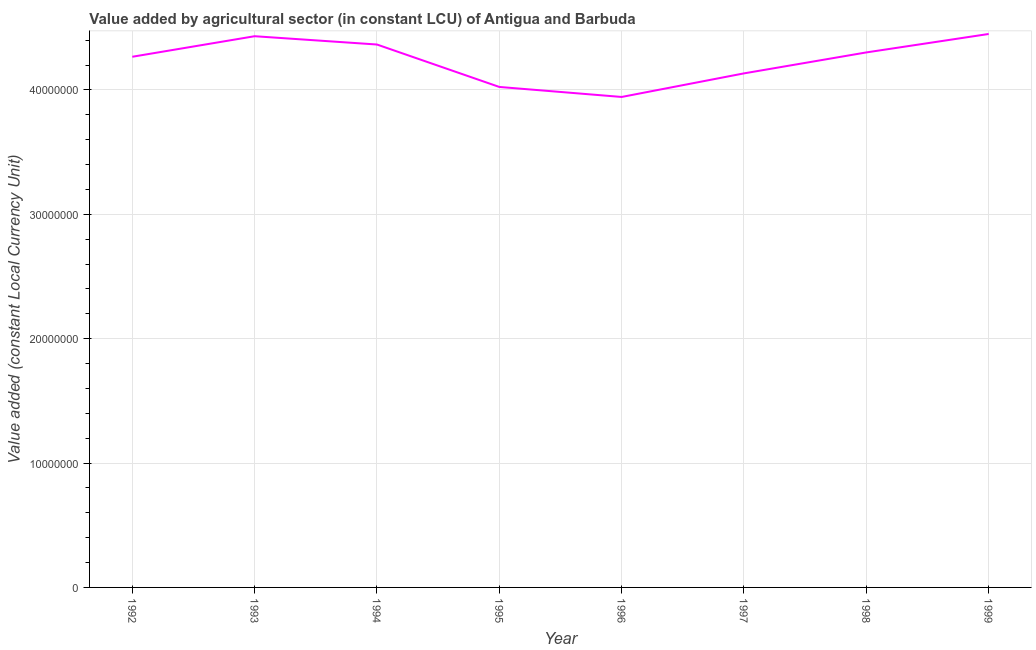What is the value added by agriculture sector in 1998?
Give a very brief answer. 4.30e+07. Across all years, what is the maximum value added by agriculture sector?
Your answer should be compact. 4.45e+07. Across all years, what is the minimum value added by agriculture sector?
Offer a very short reply. 3.94e+07. In which year was the value added by agriculture sector minimum?
Give a very brief answer. 1996. What is the sum of the value added by agriculture sector?
Offer a terse response. 3.39e+08. What is the difference between the value added by agriculture sector in 1992 and 1993?
Give a very brief answer. -1.65e+06. What is the average value added by agriculture sector per year?
Offer a very short reply. 4.24e+07. What is the median value added by agriculture sector?
Provide a short and direct response. 4.28e+07. In how many years, is the value added by agriculture sector greater than 32000000 LCU?
Provide a succinct answer. 8. Do a majority of the years between 1995 and 1999 (inclusive) have value added by agriculture sector greater than 2000000 LCU?
Ensure brevity in your answer.  Yes. What is the ratio of the value added by agriculture sector in 1993 to that in 1999?
Ensure brevity in your answer.  1. Is the difference between the value added by agriculture sector in 1993 and 1997 greater than the difference between any two years?
Ensure brevity in your answer.  No. What is the difference between the highest and the second highest value added by agriculture sector?
Make the answer very short. 1.80e+05. Is the sum of the value added by agriculture sector in 1992 and 1997 greater than the maximum value added by agriculture sector across all years?
Give a very brief answer. Yes. What is the difference between the highest and the lowest value added by agriculture sector?
Your answer should be compact. 5.06e+06. Does the value added by agriculture sector monotonically increase over the years?
Your response must be concise. No. How many lines are there?
Give a very brief answer. 1. Does the graph contain any zero values?
Keep it short and to the point. No. What is the title of the graph?
Provide a short and direct response. Value added by agricultural sector (in constant LCU) of Antigua and Barbuda. What is the label or title of the Y-axis?
Give a very brief answer. Value added (constant Local Currency Unit). What is the Value added (constant Local Currency Unit) of 1992?
Keep it short and to the point. 4.27e+07. What is the Value added (constant Local Currency Unit) of 1993?
Provide a short and direct response. 4.43e+07. What is the Value added (constant Local Currency Unit) in 1994?
Ensure brevity in your answer.  4.37e+07. What is the Value added (constant Local Currency Unit) of 1995?
Offer a very short reply. 4.02e+07. What is the Value added (constant Local Currency Unit) of 1996?
Ensure brevity in your answer.  3.94e+07. What is the Value added (constant Local Currency Unit) of 1997?
Offer a very short reply. 4.13e+07. What is the Value added (constant Local Currency Unit) of 1998?
Your answer should be very brief. 4.30e+07. What is the Value added (constant Local Currency Unit) in 1999?
Provide a succinct answer. 4.45e+07. What is the difference between the Value added (constant Local Currency Unit) in 1992 and 1993?
Your response must be concise. -1.65e+06. What is the difference between the Value added (constant Local Currency Unit) in 1992 and 1994?
Your answer should be compact. -9.85e+05. What is the difference between the Value added (constant Local Currency Unit) in 1992 and 1995?
Offer a very short reply. 2.43e+06. What is the difference between the Value added (constant Local Currency Unit) in 1992 and 1996?
Give a very brief answer. 3.23e+06. What is the difference between the Value added (constant Local Currency Unit) in 1992 and 1997?
Give a very brief answer. 1.34e+06. What is the difference between the Value added (constant Local Currency Unit) in 1992 and 1998?
Your response must be concise. -3.50e+05. What is the difference between the Value added (constant Local Currency Unit) in 1992 and 1999?
Provide a succinct answer. -1.83e+06. What is the difference between the Value added (constant Local Currency Unit) in 1993 and 1994?
Your answer should be compact. 6.68e+05. What is the difference between the Value added (constant Local Currency Unit) in 1993 and 1995?
Offer a very short reply. 4.08e+06. What is the difference between the Value added (constant Local Currency Unit) in 1993 and 1996?
Your response must be concise. 4.88e+06. What is the difference between the Value added (constant Local Currency Unit) in 1993 and 1997?
Offer a terse response. 2.99e+06. What is the difference between the Value added (constant Local Currency Unit) in 1993 and 1998?
Ensure brevity in your answer.  1.30e+06. What is the difference between the Value added (constant Local Currency Unit) in 1993 and 1999?
Give a very brief answer. -1.80e+05. What is the difference between the Value added (constant Local Currency Unit) in 1994 and 1995?
Offer a terse response. 3.41e+06. What is the difference between the Value added (constant Local Currency Unit) in 1994 and 1996?
Offer a terse response. 4.22e+06. What is the difference between the Value added (constant Local Currency Unit) in 1994 and 1997?
Offer a very short reply. 2.32e+06. What is the difference between the Value added (constant Local Currency Unit) in 1994 and 1998?
Your response must be concise. 6.36e+05. What is the difference between the Value added (constant Local Currency Unit) in 1994 and 1999?
Your answer should be compact. -8.48e+05. What is the difference between the Value added (constant Local Currency Unit) in 1995 and 1996?
Provide a short and direct response. 8.05e+05. What is the difference between the Value added (constant Local Currency Unit) in 1995 and 1997?
Keep it short and to the point. -1.09e+06. What is the difference between the Value added (constant Local Currency Unit) in 1995 and 1998?
Make the answer very short. -2.78e+06. What is the difference between the Value added (constant Local Currency Unit) in 1995 and 1999?
Ensure brevity in your answer.  -4.26e+06. What is the difference between the Value added (constant Local Currency Unit) in 1996 and 1997?
Offer a very short reply. -1.90e+06. What is the difference between the Value added (constant Local Currency Unit) in 1996 and 1998?
Give a very brief answer. -3.58e+06. What is the difference between the Value added (constant Local Currency Unit) in 1996 and 1999?
Offer a very short reply. -5.06e+06. What is the difference between the Value added (constant Local Currency Unit) in 1997 and 1998?
Your answer should be very brief. -1.68e+06. What is the difference between the Value added (constant Local Currency Unit) in 1997 and 1999?
Offer a very short reply. -3.17e+06. What is the difference between the Value added (constant Local Currency Unit) in 1998 and 1999?
Offer a very short reply. -1.48e+06. What is the ratio of the Value added (constant Local Currency Unit) in 1992 to that in 1993?
Give a very brief answer. 0.96. What is the ratio of the Value added (constant Local Currency Unit) in 1992 to that in 1994?
Your response must be concise. 0.98. What is the ratio of the Value added (constant Local Currency Unit) in 1992 to that in 1995?
Offer a terse response. 1.06. What is the ratio of the Value added (constant Local Currency Unit) in 1992 to that in 1996?
Make the answer very short. 1.08. What is the ratio of the Value added (constant Local Currency Unit) in 1992 to that in 1997?
Your answer should be compact. 1.03. What is the ratio of the Value added (constant Local Currency Unit) in 1992 to that in 1998?
Provide a short and direct response. 0.99. What is the ratio of the Value added (constant Local Currency Unit) in 1992 to that in 1999?
Make the answer very short. 0.96. What is the ratio of the Value added (constant Local Currency Unit) in 1993 to that in 1995?
Offer a terse response. 1.1. What is the ratio of the Value added (constant Local Currency Unit) in 1993 to that in 1996?
Your answer should be very brief. 1.12. What is the ratio of the Value added (constant Local Currency Unit) in 1993 to that in 1997?
Give a very brief answer. 1.07. What is the ratio of the Value added (constant Local Currency Unit) in 1994 to that in 1995?
Offer a very short reply. 1.08. What is the ratio of the Value added (constant Local Currency Unit) in 1994 to that in 1996?
Make the answer very short. 1.11. What is the ratio of the Value added (constant Local Currency Unit) in 1994 to that in 1997?
Offer a terse response. 1.06. What is the ratio of the Value added (constant Local Currency Unit) in 1995 to that in 1997?
Offer a very short reply. 0.97. What is the ratio of the Value added (constant Local Currency Unit) in 1995 to that in 1998?
Ensure brevity in your answer.  0.94. What is the ratio of the Value added (constant Local Currency Unit) in 1995 to that in 1999?
Provide a short and direct response. 0.9. What is the ratio of the Value added (constant Local Currency Unit) in 1996 to that in 1997?
Offer a very short reply. 0.95. What is the ratio of the Value added (constant Local Currency Unit) in 1996 to that in 1998?
Offer a terse response. 0.92. What is the ratio of the Value added (constant Local Currency Unit) in 1996 to that in 1999?
Your answer should be compact. 0.89. What is the ratio of the Value added (constant Local Currency Unit) in 1997 to that in 1998?
Your answer should be compact. 0.96. What is the ratio of the Value added (constant Local Currency Unit) in 1997 to that in 1999?
Provide a short and direct response. 0.93. What is the ratio of the Value added (constant Local Currency Unit) in 1998 to that in 1999?
Your answer should be compact. 0.97. 